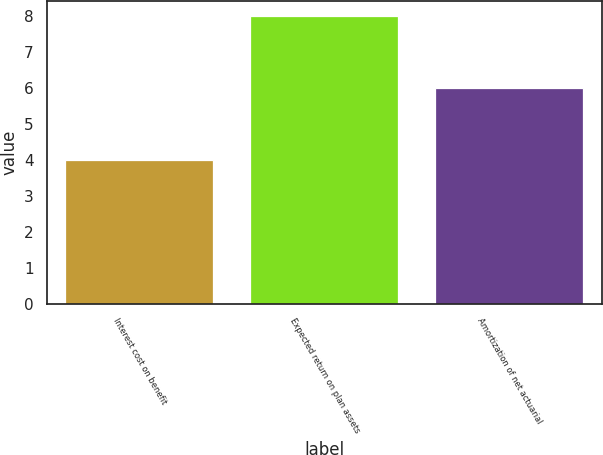Convert chart. <chart><loc_0><loc_0><loc_500><loc_500><bar_chart><fcel>Interest cost on benefit<fcel>Expected return on plan assets<fcel>Amortization of net actuarial<nl><fcel>4<fcel>8<fcel>6<nl></chart> 